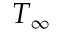<formula> <loc_0><loc_0><loc_500><loc_500>T _ { \infty }</formula> 